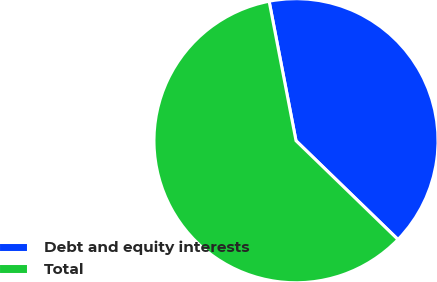Convert chart to OTSL. <chart><loc_0><loc_0><loc_500><loc_500><pie_chart><fcel>Debt and equity interests<fcel>Total<nl><fcel>40.28%<fcel>59.72%<nl></chart> 